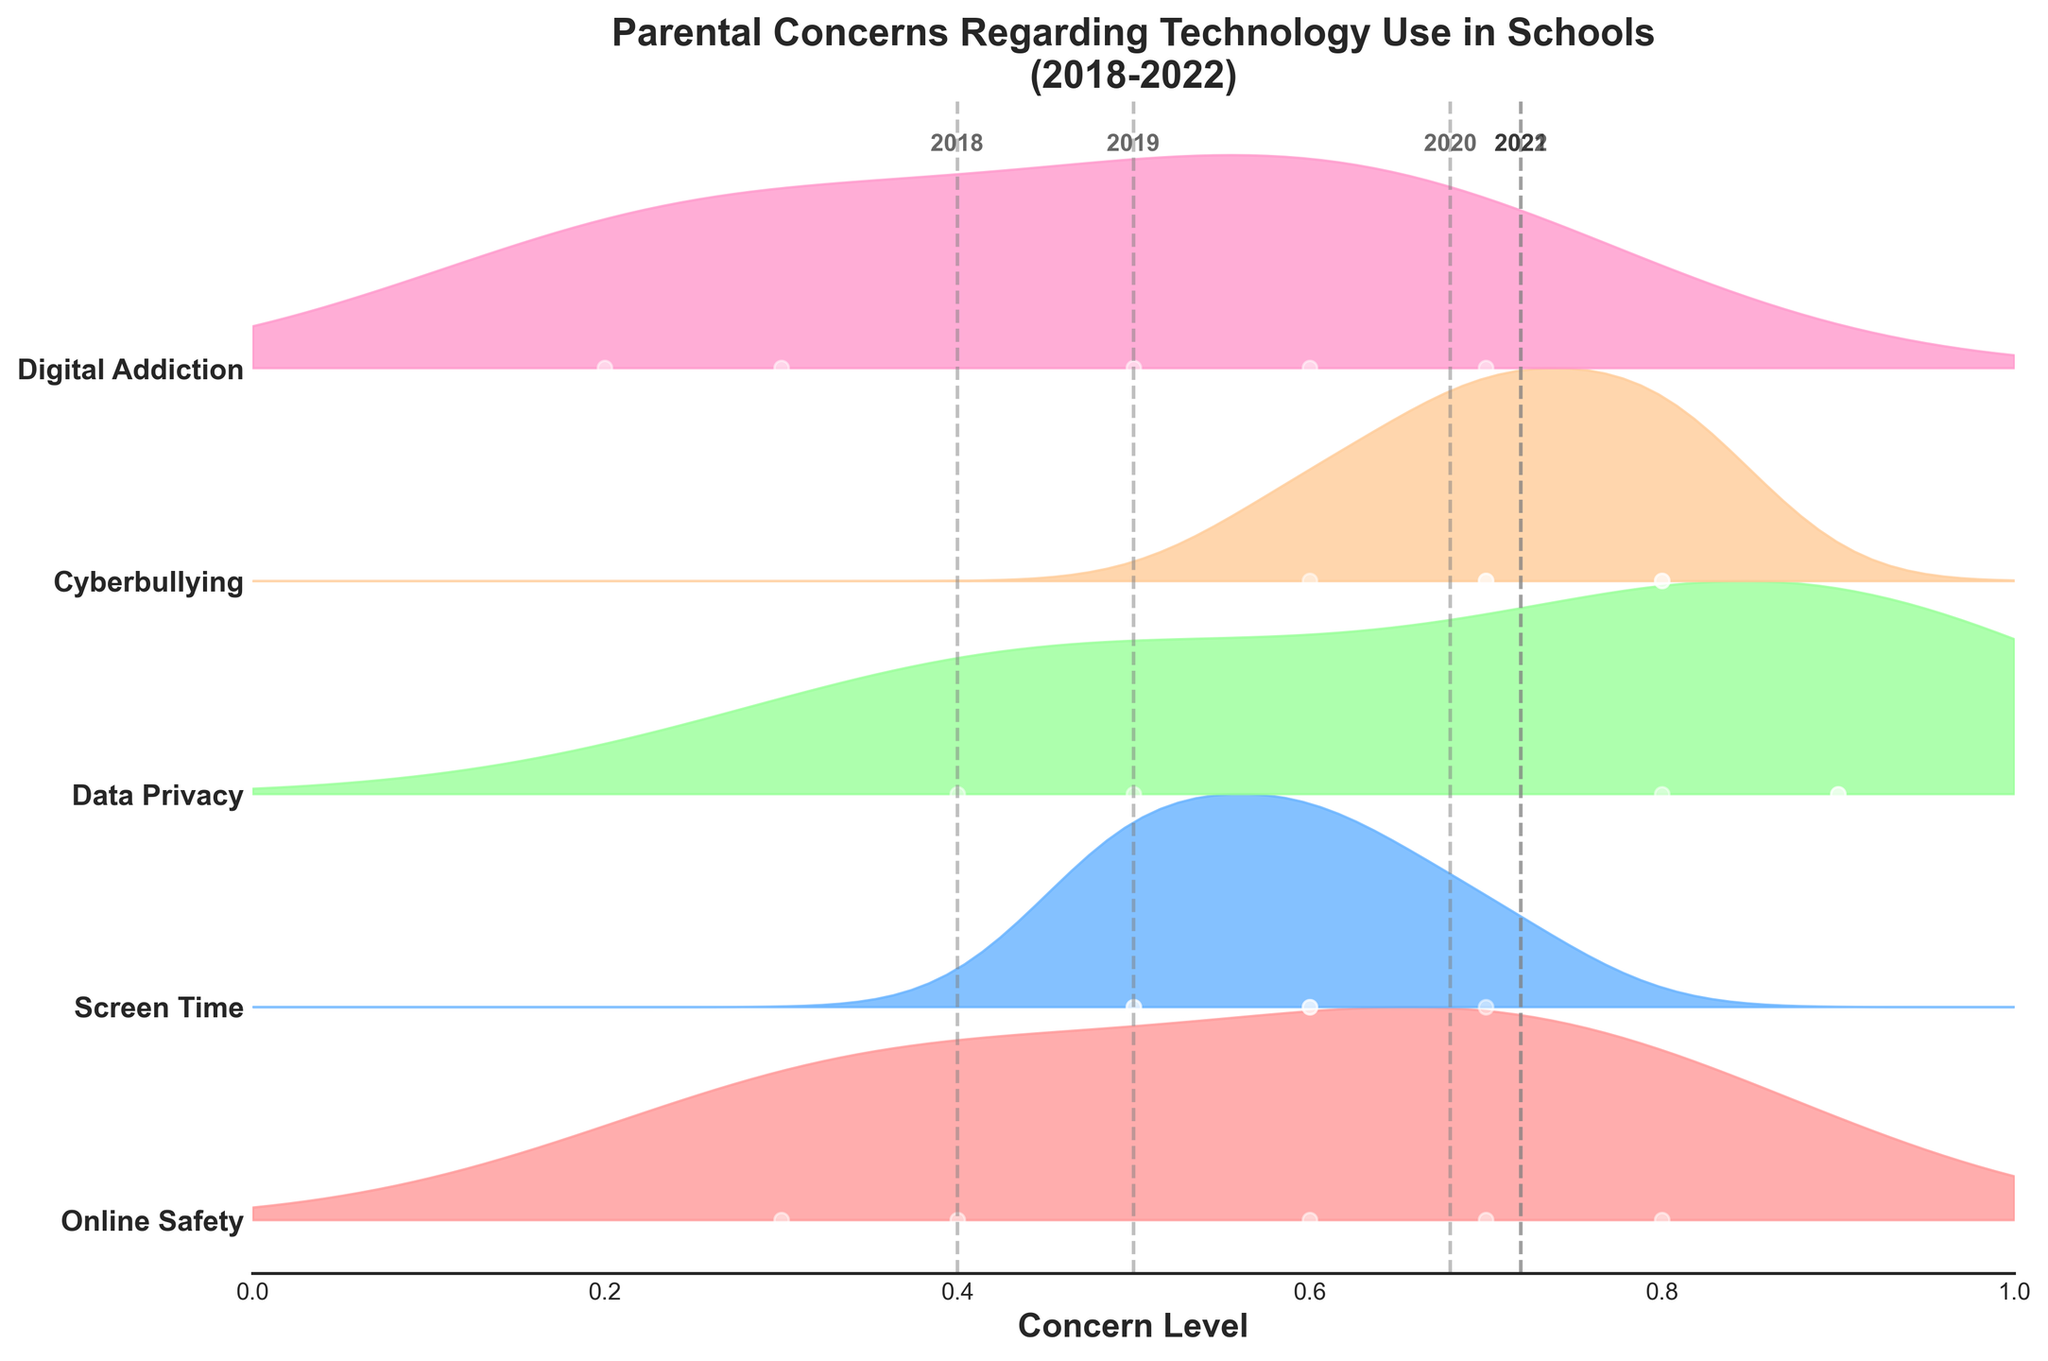What is the title of the figure? The title of the figure is displayed at the top and usually summarizes what the plot is about.
Answer: Parental Concerns Regarding Technology Use in Schools (2018-2022) Which issue shows the highest concern level in 2021? To determine which issue has the highest concern level, look at the individual density peaks for the year 2021. The highest peak indicates the highest concern level.
Answer: Data Privacy How does the concern level for Online Safety change from 2018 to 2022? Trace the line for Online Safety from 2018 to 2022 on the plot to observe the trend. It starts at 0.3 in 2018 and increases to 0.8 by 2022.
Answer: It increases Which year generally has the highest concern levels across all issues, and how can you tell? Compare the vertical lines representing average concern levels for each year. The highest average line will indicate the year with the highest general concern.
Answer: 2021 How does the concern for Cyberbullying change from 2018 to 2022? Follow the plot points and density curves for Cyberbullying from 2018 to 2022 to track the changes in concern levels.
Answer: It starts at 0.6 in 2018, peaks at 0.8 in 2020 and 2021, and then decreases slightly to 0.7 in 2022 What is the trend for Screen Time concerns over the years? Look at the concern levels for Screen Time for each year from 2018 to 2022 to identify any increasing or decreasing pattern.
Answer: Generally fluctuates slightly but starts at 0.5 in 2018 and ends at 0.5 in 2022 Which issue had the most consistent concern level over the years? Check all issues and observe which has the least variation in its concern level across the years.
Answer: Digital Addiction Compare the concern levels for Data Privacy and Online Safety in 2020. Which one is higher? Look at the density peaks and the data points for both Data Privacy and Online Safety in 2020.
Answer: Data Privacy How can you identify the different issues in the plot? Each issue is represented with a different color, and their names are listed on the y-axis.
Answer: Different colors and y-axis labels 